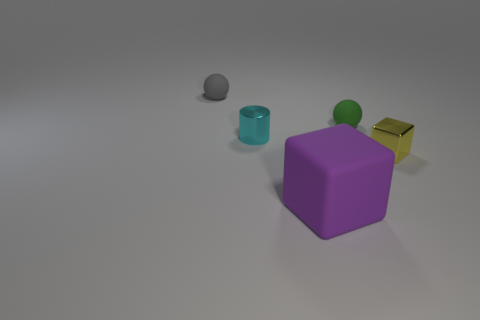Add 5 tiny cyan objects. How many objects exist? 10 Subtract all cubes. How many objects are left? 3 Subtract all matte objects. Subtract all tiny gray rubber things. How many objects are left? 1 Add 5 gray things. How many gray things are left? 6 Add 4 tiny yellow shiny objects. How many tiny yellow shiny objects exist? 5 Subtract 0 gray cubes. How many objects are left? 5 